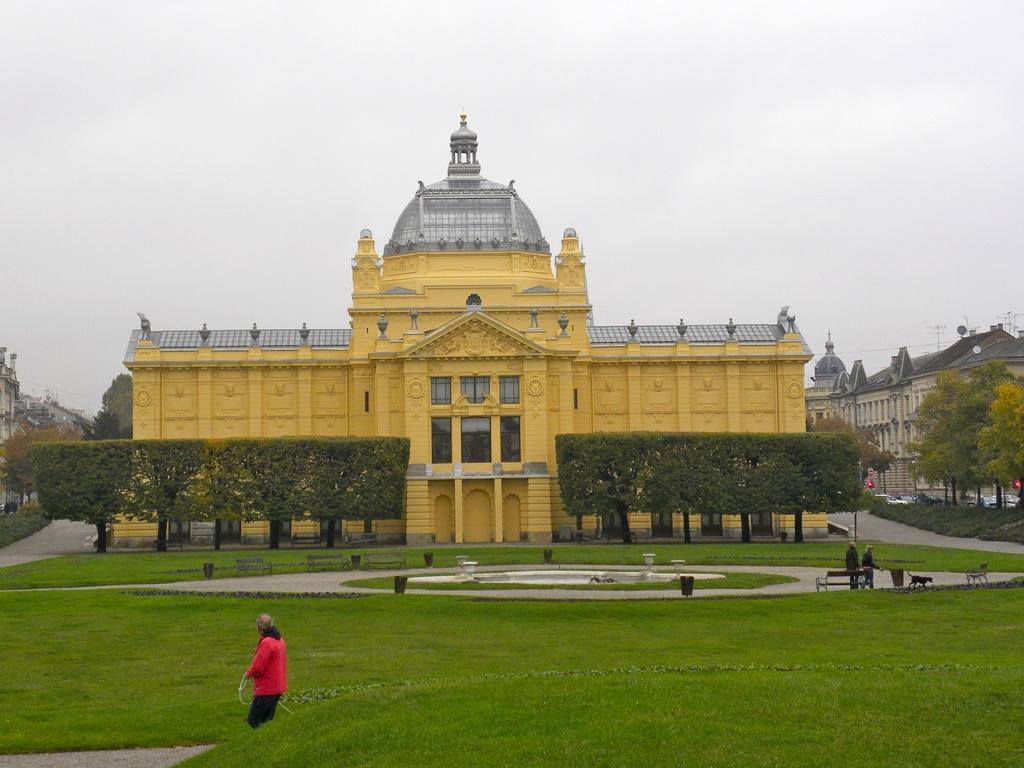Can you describe this image briefly? In the foreground I can see grass, a person is holding a pipe in hand, fountain, lights, two persons are walking on the road, benches, box and an animal. In the background I can see buildings, trees, glass, light poles, fleets of vehicles on the road, boards and the sky. This image is taken may be during a day. 